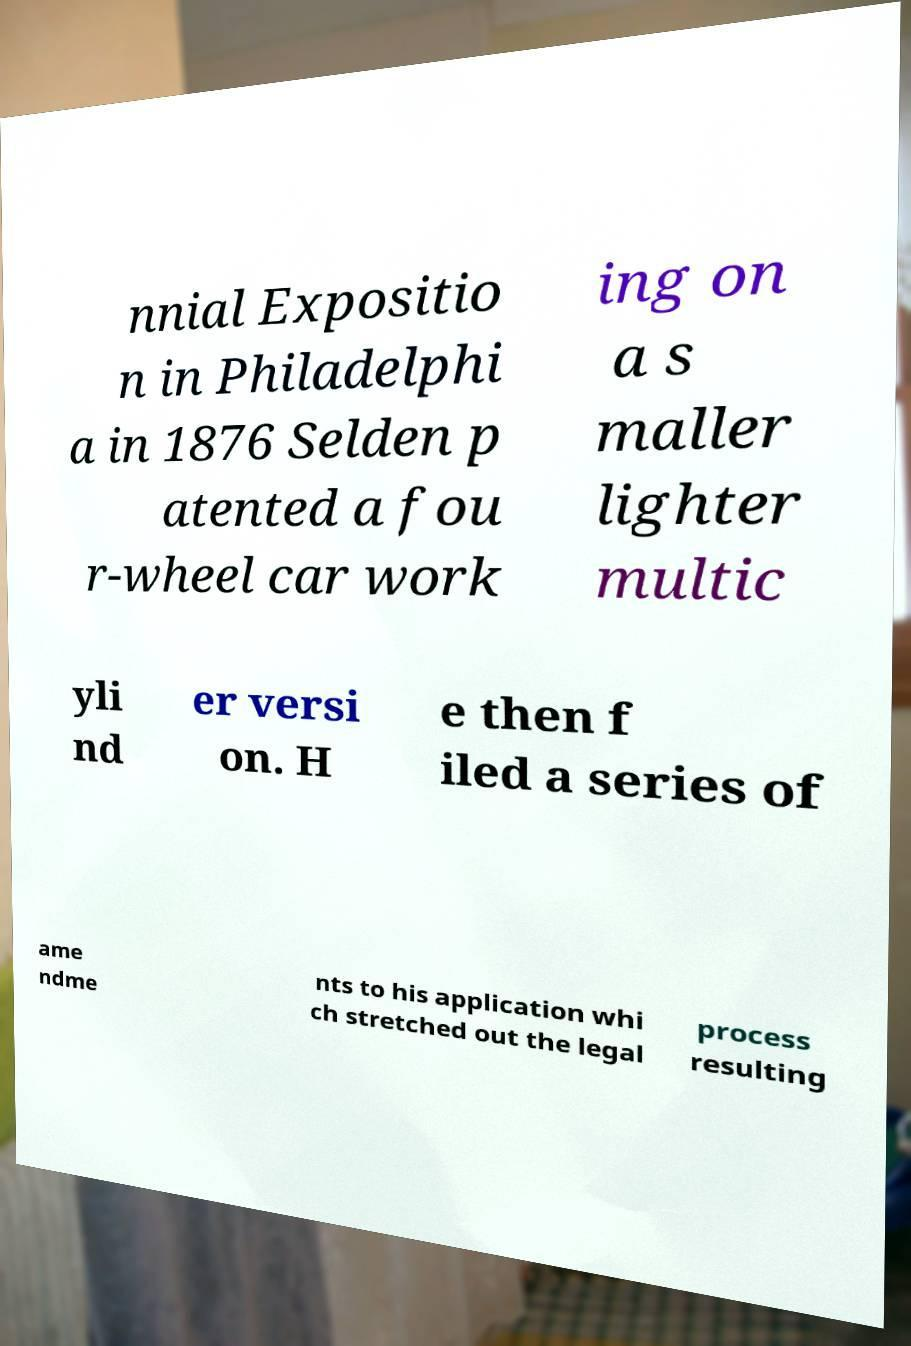I need the written content from this picture converted into text. Can you do that? nnial Expositio n in Philadelphi a in 1876 Selden p atented a fou r-wheel car work ing on a s maller lighter multic yli nd er versi on. H e then f iled a series of ame ndme nts to his application whi ch stretched out the legal process resulting 